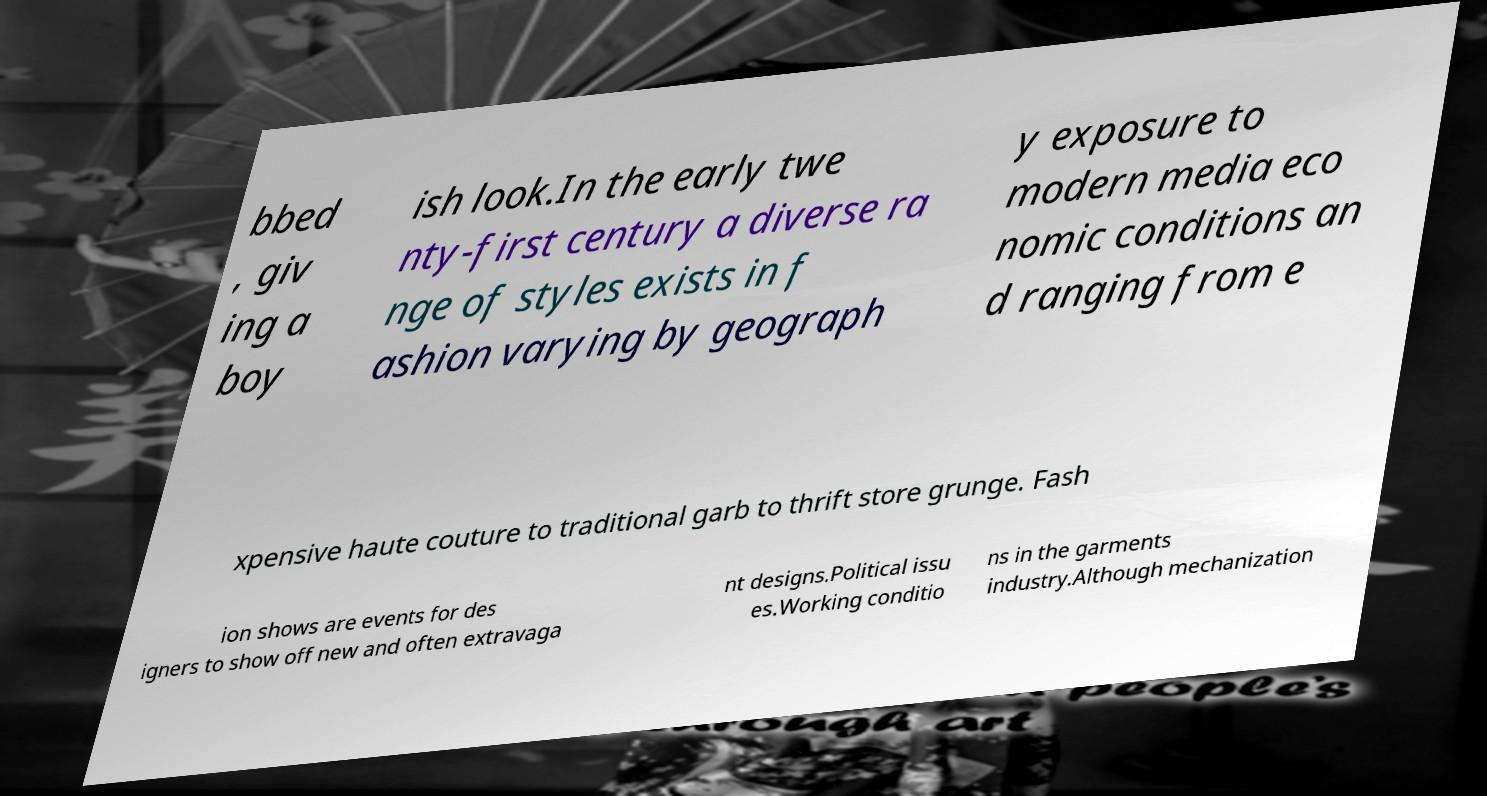Can you read and provide the text displayed in the image?This photo seems to have some interesting text. Can you extract and type it out for me? bbed , giv ing a boy ish look.In the early twe nty-first century a diverse ra nge of styles exists in f ashion varying by geograph y exposure to modern media eco nomic conditions an d ranging from e xpensive haute couture to traditional garb to thrift store grunge. Fash ion shows are events for des igners to show off new and often extravaga nt designs.Political issu es.Working conditio ns in the garments industry.Although mechanization 